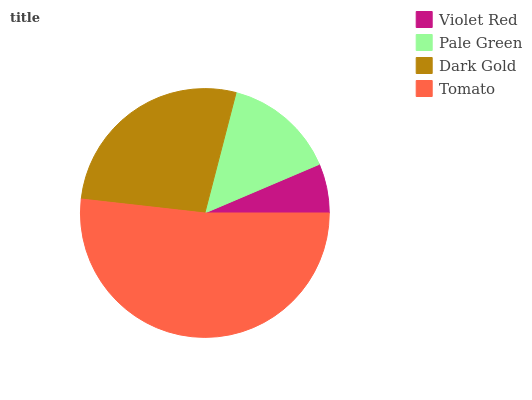Is Violet Red the minimum?
Answer yes or no. Yes. Is Tomato the maximum?
Answer yes or no. Yes. Is Pale Green the minimum?
Answer yes or no. No. Is Pale Green the maximum?
Answer yes or no. No. Is Pale Green greater than Violet Red?
Answer yes or no. Yes. Is Violet Red less than Pale Green?
Answer yes or no. Yes. Is Violet Red greater than Pale Green?
Answer yes or no. No. Is Pale Green less than Violet Red?
Answer yes or no. No. Is Dark Gold the high median?
Answer yes or no. Yes. Is Pale Green the low median?
Answer yes or no. Yes. Is Violet Red the high median?
Answer yes or no. No. Is Tomato the low median?
Answer yes or no. No. 